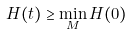Convert formula to latex. <formula><loc_0><loc_0><loc_500><loc_500>H ( t ) \geq \min _ { M } H ( 0 )</formula> 